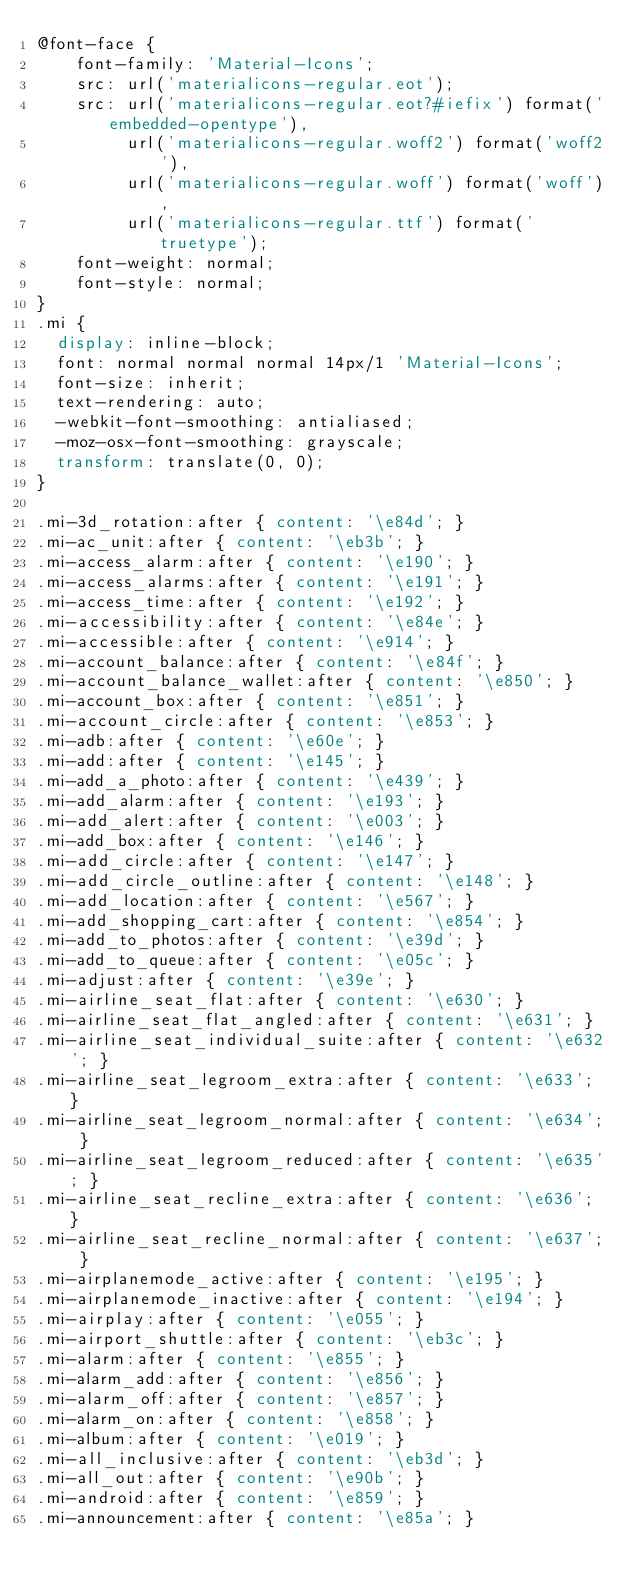<code> <loc_0><loc_0><loc_500><loc_500><_CSS_>@font-face {
    font-family: 'Material-Icons';
    src: url('materialicons-regular.eot');
    src: url('materialicons-regular.eot?#iefix') format('embedded-opentype'),
         url('materialicons-regular.woff2') format('woff2'),
         url('materialicons-regular.woff') format('woff'),
         url('materialicons-regular.ttf') format('truetype');
    font-weight: normal;
    font-style: normal;
}
.mi {
  display: inline-block;
  font: normal normal normal 14px/1 'Material-Icons';
  font-size: inherit;
  text-rendering: auto;
  -webkit-font-smoothing: antialiased;
  -moz-osx-font-smoothing: grayscale;
  transform: translate(0, 0);
}

.mi-3d_rotation:after { content: '\e84d'; }
.mi-ac_unit:after { content: '\eb3b'; }
.mi-access_alarm:after { content: '\e190'; }
.mi-access_alarms:after { content: '\e191'; }
.mi-access_time:after { content: '\e192'; }
.mi-accessibility:after { content: '\e84e'; }
.mi-accessible:after { content: '\e914'; }
.mi-account_balance:after { content: '\e84f'; }
.mi-account_balance_wallet:after { content: '\e850'; }
.mi-account_box:after { content: '\e851'; }
.mi-account_circle:after { content: '\e853'; }
.mi-adb:after { content: '\e60e'; }
.mi-add:after { content: '\e145'; }
.mi-add_a_photo:after { content: '\e439'; }
.mi-add_alarm:after { content: '\e193'; }
.mi-add_alert:after { content: '\e003'; }
.mi-add_box:after { content: '\e146'; }
.mi-add_circle:after { content: '\e147'; }
.mi-add_circle_outline:after { content: '\e148'; }
.mi-add_location:after { content: '\e567'; }
.mi-add_shopping_cart:after { content: '\e854'; }
.mi-add_to_photos:after { content: '\e39d'; }
.mi-add_to_queue:after { content: '\e05c'; }
.mi-adjust:after { content: '\e39e'; }
.mi-airline_seat_flat:after { content: '\e630'; }
.mi-airline_seat_flat_angled:after { content: '\e631'; }
.mi-airline_seat_individual_suite:after { content: '\e632'; }
.mi-airline_seat_legroom_extra:after { content: '\e633'; }
.mi-airline_seat_legroom_normal:after { content: '\e634'; }
.mi-airline_seat_legroom_reduced:after { content: '\e635'; }
.mi-airline_seat_recline_extra:after { content: '\e636'; }
.mi-airline_seat_recline_normal:after { content: '\e637'; }
.mi-airplanemode_active:after { content: '\e195'; }
.mi-airplanemode_inactive:after { content: '\e194'; }
.mi-airplay:after { content: '\e055'; }
.mi-airport_shuttle:after { content: '\eb3c'; }
.mi-alarm:after { content: '\e855'; }
.mi-alarm_add:after { content: '\e856'; }
.mi-alarm_off:after { content: '\e857'; }
.mi-alarm_on:after { content: '\e858'; }
.mi-album:after { content: '\e019'; }
.mi-all_inclusive:after { content: '\eb3d'; }
.mi-all_out:after { content: '\e90b'; }
.mi-android:after { content: '\e859'; }
.mi-announcement:after { content: '\e85a'; }</code> 